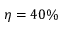Convert formula to latex. <formula><loc_0><loc_0><loc_500><loc_500>\eta = 4 0 \%</formula> 